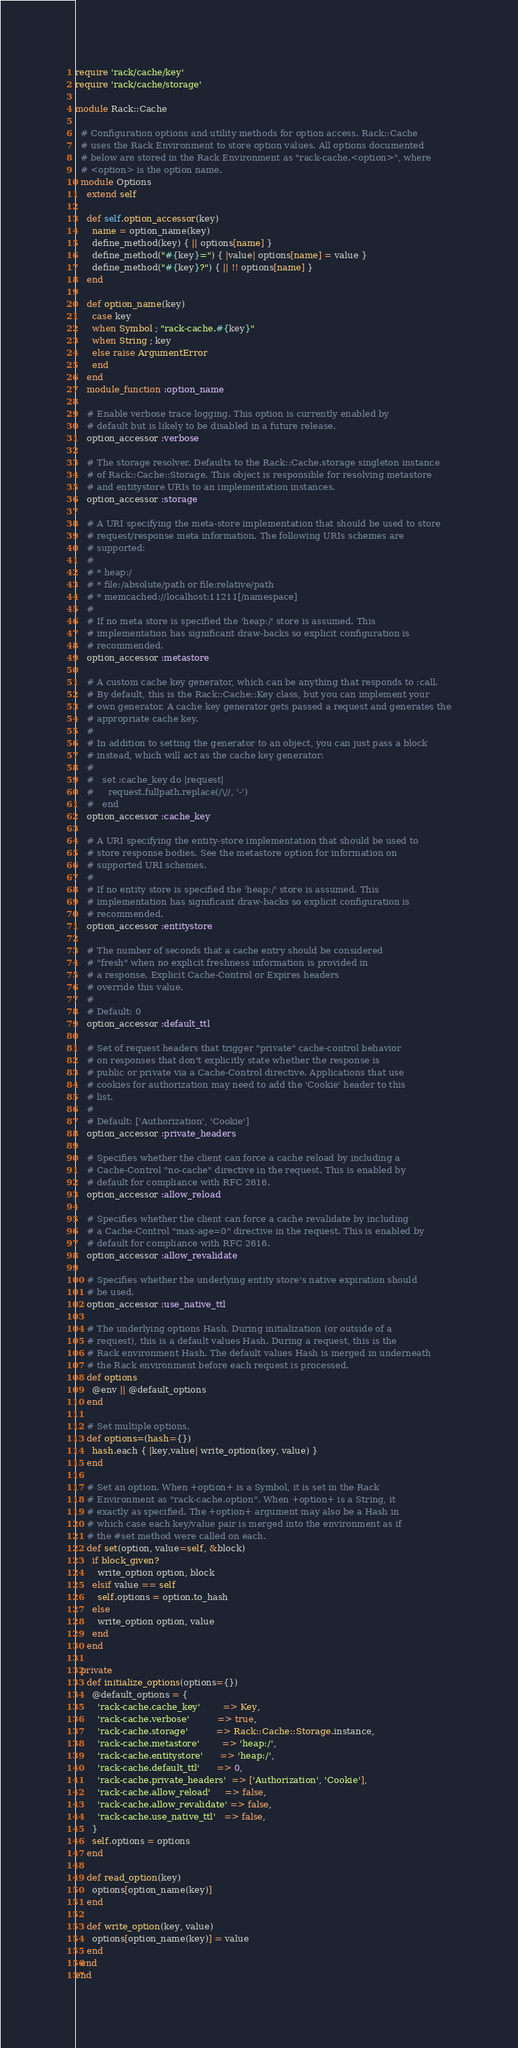Convert code to text. <code><loc_0><loc_0><loc_500><loc_500><_Ruby_>require 'rack/cache/key'
require 'rack/cache/storage'

module Rack::Cache

  # Configuration options and utility methods for option access. Rack::Cache
  # uses the Rack Environment to store option values. All options documented
  # below are stored in the Rack Environment as "rack-cache.<option>", where
  # <option> is the option name.
  module Options
    extend self

    def self.option_accessor(key)
      name = option_name(key)
      define_method(key) { || options[name] }
      define_method("#{key}=") { |value| options[name] = value }
      define_method("#{key}?") { || !! options[name] }
    end

    def option_name(key)
      case key
      when Symbol ; "rack-cache.#{key}"
      when String ; key
      else raise ArgumentError
      end
    end
    module_function :option_name

    # Enable verbose trace logging. This option is currently enabled by
    # default but is likely to be disabled in a future release.
    option_accessor :verbose

    # The storage resolver. Defaults to the Rack::Cache.storage singleton instance
    # of Rack::Cache::Storage. This object is responsible for resolving metastore
    # and entitystore URIs to an implementation instances.
    option_accessor :storage

    # A URI specifying the meta-store implementation that should be used to store
    # request/response meta information. The following URIs schemes are
    # supported:
    #
    # * heap:/
    # * file:/absolute/path or file:relative/path
    # * memcached://localhost:11211[/namespace]
    #
    # If no meta store is specified the 'heap:/' store is assumed. This
    # implementation has significant draw-backs so explicit configuration is
    # recommended.
    option_accessor :metastore

    # A custom cache key generator, which can be anything that responds to :call.
    # By default, this is the Rack::Cache::Key class, but you can implement your
    # own generator. A cache key generator gets passed a request and generates the
    # appropriate cache key.
    #
    # In addition to setting the generator to an object, you can just pass a block
    # instead, which will act as the cache key generator:
    #
    #   set :cache_key do |request|
    #     request.fullpath.replace(/\//, '-')
    #   end
    option_accessor :cache_key

    # A URI specifying the entity-store implementation that should be used to
    # store response bodies. See the metastore option for information on
    # supported URI schemes.
    #
    # If no entity store is specified the 'heap:/' store is assumed. This
    # implementation has significant draw-backs so explicit configuration is
    # recommended.
    option_accessor :entitystore

    # The number of seconds that a cache entry should be considered
    # "fresh" when no explicit freshness information is provided in
    # a response. Explicit Cache-Control or Expires headers
    # override this value.
    #
    # Default: 0
    option_accessor :default_ttl

    # Set of request headers that trigger "private" cache-control behavior
    # on responses that don't explicitly state whether the response is
    # public or private via a Cache-Control directive. Applications that use
    # cookies for authorization may need to add the 'Cookie' header to this
    # list.
    #
    # Default: ['Authorization', 'Cookie']
    option_accessor :private_headers

    # Specifies whether the client can force a cache reload by including a
    # Cache-Control "no-cache" directive in the request. This is enabled by
    # default for compliance with RFC 2616.
    option_accessor :allow_reload

    # Specifies whether the client can force a cache revalidate by including
    # a Cache-Control "max-age=0" directive in the request. This is enabled by
    # default for compliance with RFC 2616.
    option_accessor :allow_revalidate

    # Specifies whether the underlying entity store's native expiration should
    # be used.
    option_accessor :use_native_ttl

    # The underlying options Hash. During initialization (or outside of a
    # request), this is a default values Hash. During a request, this is the
    # Rack environment Hash. The default values Hash is merged in underneath
    # the Rack environment before each request is processed.
    def options
      @env || @default_options
    end

    # Set multiple options.
    def options=(hash={})
      hash.each { |key,value| write_option(key, value) }
    end

    # Set an option. When +option+ is a Symbol, it is set in the Rack
    # Environment as "rack-cache.option". When +option+ is a String, it
    # exactly as specified. The +option+ argument may also be a Hash in
    # which case each key/value pair is merged into the environment as if
    # the #set method were called on each.
    def set(option, value=self, &block)
      if block_given?
        write_option option, block
      elsif value == self
        self.options = option.to_hash
      else
        write_option option, value
      end
    end

  private
    def initialize_options(options={})
      @default_options = {
        'rack-cache.cache_key'        => Key,
        'rack-cache.verbose'          => true,
        'rack-cache.storage'          => Rack::Cache::Storage.instance,
        'rack-cache.metastore'        => 'heap:/',
        'rack-cache.entitystore'      => 'heap:/',
        'rack-cache.default_ttl'      => 0,
        'rack-cache.private_headers'  => ['Authorization', 'Cookie'],
        'rack-cache.allow_reload'     => false,
        'rack-cache.allow_revalidate' => false,
        'rack-cache.use_native_ttl'   => false,
      }
      self.options = options
    end

    def read_option(key)
      options[option_name(key)]
    end

    def write_option(key, value)
      options[option_name(key)] = value
    end
  end
end
</code> 